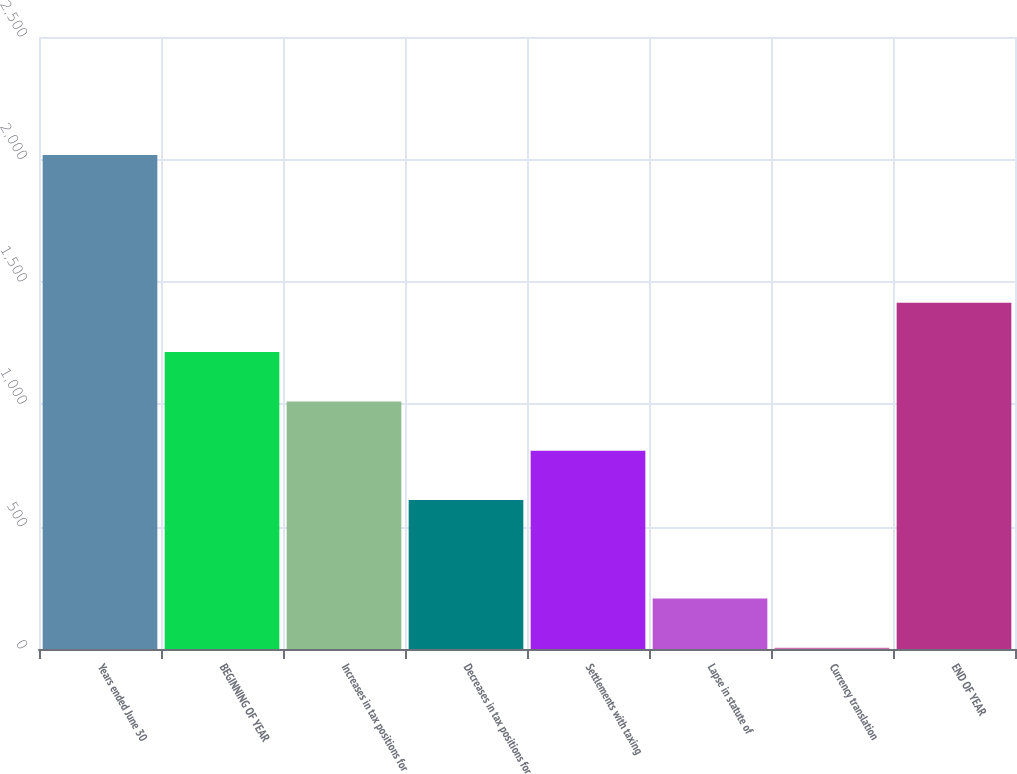Convert chart to OTSL. <chart><loc_0><loc_0><loc_500><loc_500><bar_chart><fcel>Years ended June 30<fcel>BEGINNING OF YEAR<fcel>Increases in tax positions for<fcel>Decreases in tax positions for<fcel>Settlements with taxing<fcel>Lapse in statute of<fcel>Currency translation<fcel>END OF YEAR<nl><fcel>2018<fcel>1212.8<fcel>1011.5<fcel>608.9<fcel>810.2<fcel>206.3<fcel>5<fcel>1414.1<nl></chart> 